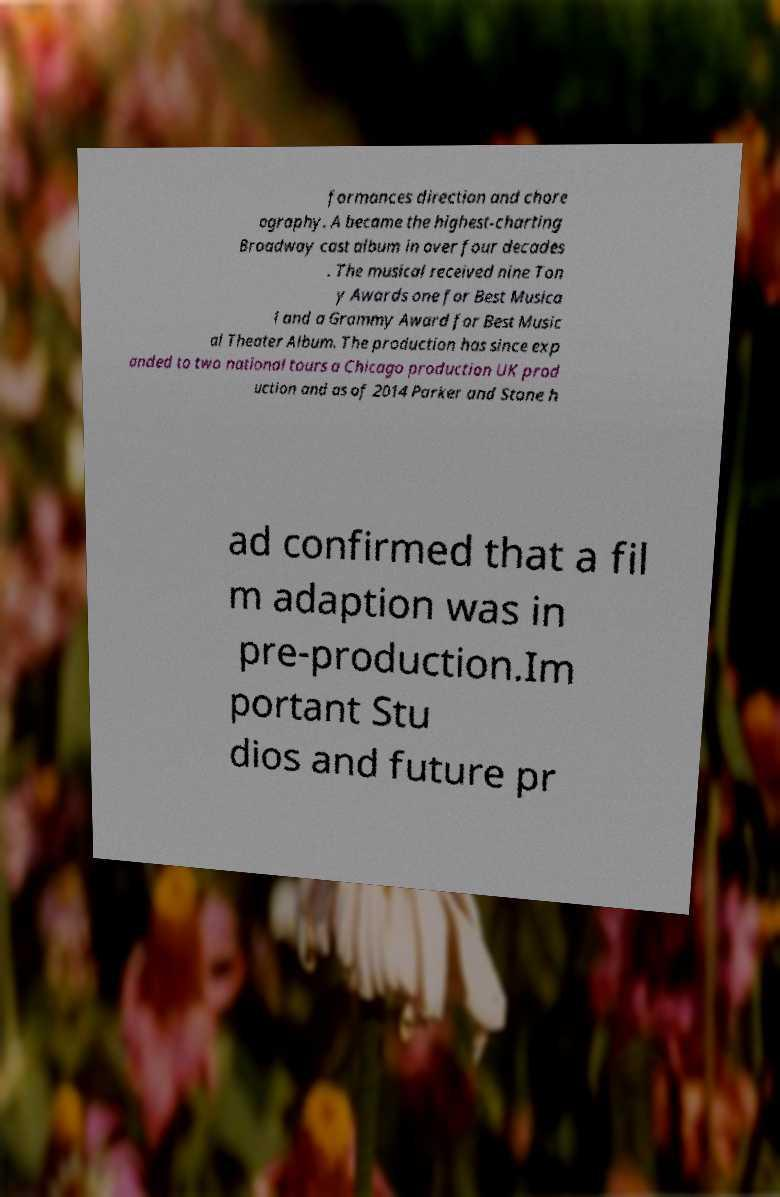Can you accurately transcribe the text from the provided image for me? formances direction and chore ography. A became the highest-charting Broadway cast album in over four decades . The musical received nine Ton y Awards one for Best Musica l and a Grammy Award for Best Music al Theater Album. The production has since exp anded to two national tours a Chicago production UK prod uction and as of 2014 Parker and Stone h ad confirmed that a fil m adaption was in pre-production.Im portant Stu dios and future pr 